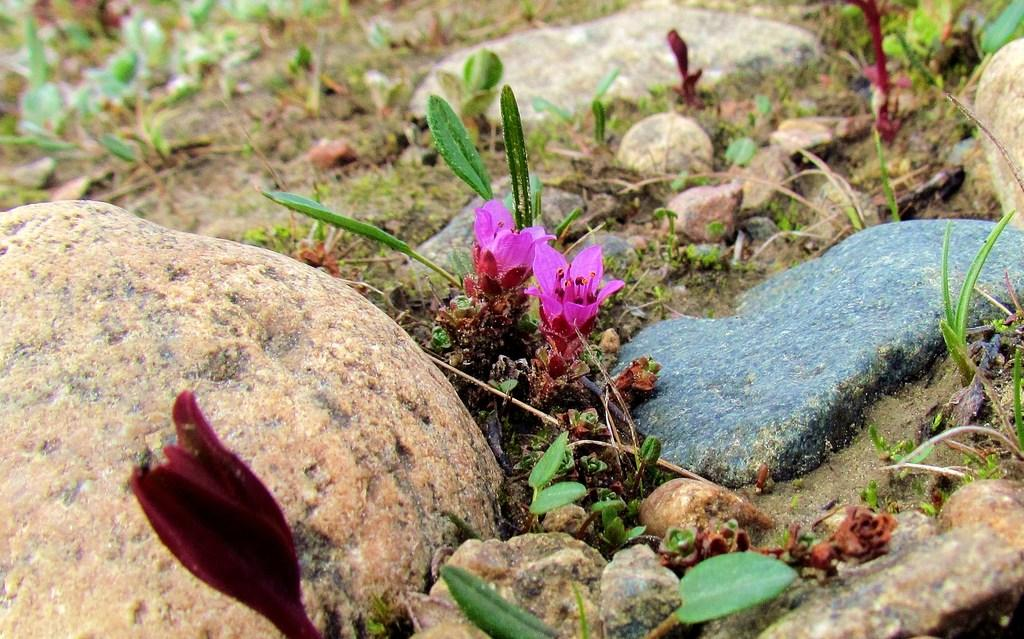What colors are the flowers in the image? The flowers in the image are in pink and red colors. What else can be seen on the ground in the image? There are small plants on the ground in the image. What type of natural elements are visible in the image? There are many rocks and green grass present on the ground in the image. How many jellyfish can be seen swimming in the image? There are no jellyfish present in the image; it features flowers, small plants, rocks, and green grass. What type of ear is visible in the image? There is no ear present in the image. 